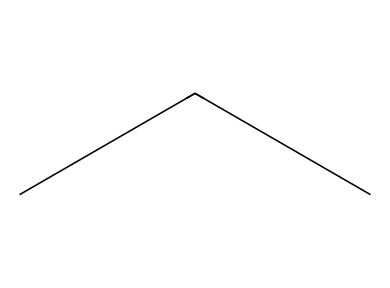What is the name of this chemical? The structure represented by the SMILES CCC corresponds to propane, as it consists of three carbon atoms bonded together in a straight chain.
Answer: propane How many carbon atoms are present in the structure? By analyzing the SMILES representation CCC, we see there are three 'C' symbols indicating three carbon atoms.
Answer: three What type of chemical bond connects the carbon atoms in this structure? The structure consists of carbon atoms that are bonded by single covalent bonds, as indicated by the absence of any double or triple bonds in the SMILES.
Answer: single What is the molecular formula for propane? The molecular formula can be determined from the number of carbon (C) and hydrogen (H) atoms. Propane has three carbon atoms and eight hydrogen atoms, resulting in the formula C3H8.
Answer: C3H8 Is propane considered a greenhouse gas? Propane does have global warming potential, but it is not categorized as a greenhouse gas to the same extent as carbon dioxide or methane, making it less impactful; thus, it is promoted as an eco-friendly refrigerant.
Answer: no In terms of refrigerant properties, is propane a saturated or unsaturated refrigerant? Propane is a saturated refrigerant because it exists as a single molecule at room temperature and pressure without any double bonds.
Answer: saturated 